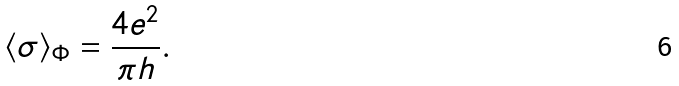<formula> <loc_0><loc_0><loc_500><loc_500>\langle \sigma \rangle _ { \Phi } = \frac { 4 e ^ { 2 } } { \pi h } .</formula> 